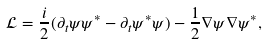Convert formula to latex. <formula><loc_0><loc_0><loc_500><loc_500>\mathcal { L } = \frac { i } { 2 } ( \partial _ { t } \psi \psi ^ { * } - \partial _ { t } \psi ^ { * } \psi ) - \frac { 1 } { 2 } \nabla \psi \nabla \psi ^ { * } ,</formula> 